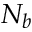<formula> <loc_0><loc_0><loc_500><loc_500>N _ { b }</formula> 